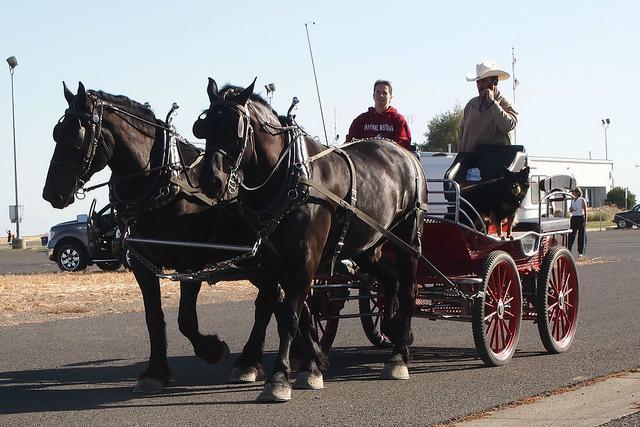What are the horses doing?
Choose the correct response and explain in the format: 'Answer: answer
Rationale: rationale.'
Options: Resting, feeding, pulling cart, posing. Answer: pulling cart.
Rationale: The horses have a cart and are going down the street. 